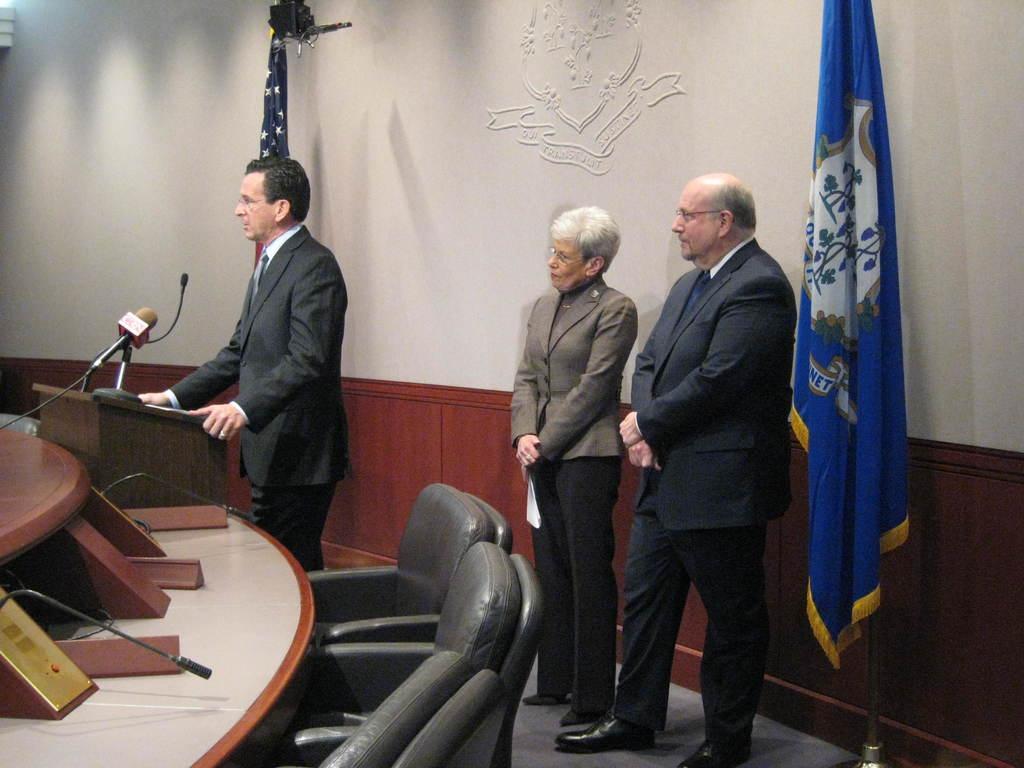How would you summarize this image in a sentence or two? In this picture there is a man wearing a grey suit is standing. There is a woman and another man is also standing. There is a flag. There is a chair and a mic. 